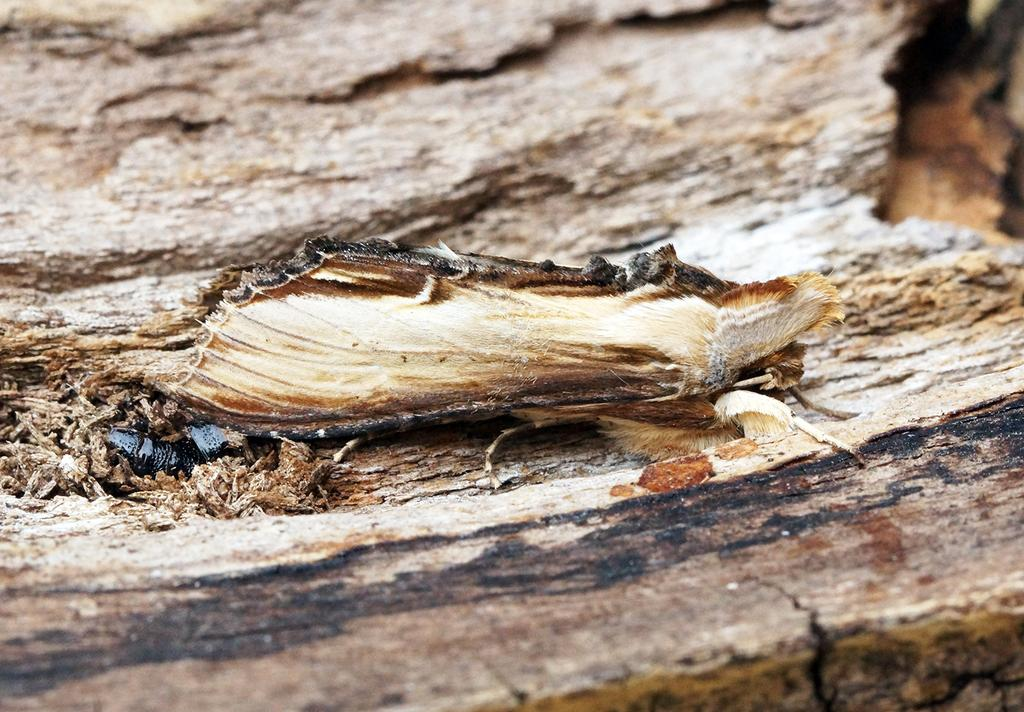What type of creature can be seen in the image? There is an insect in the image. What is the insect sitting on in the image? The insect is on a wooden surface. What type of grass is growing around the dolls in the image? There are no dolls or grass present in the image; it only features an insect on a wooden surface. 